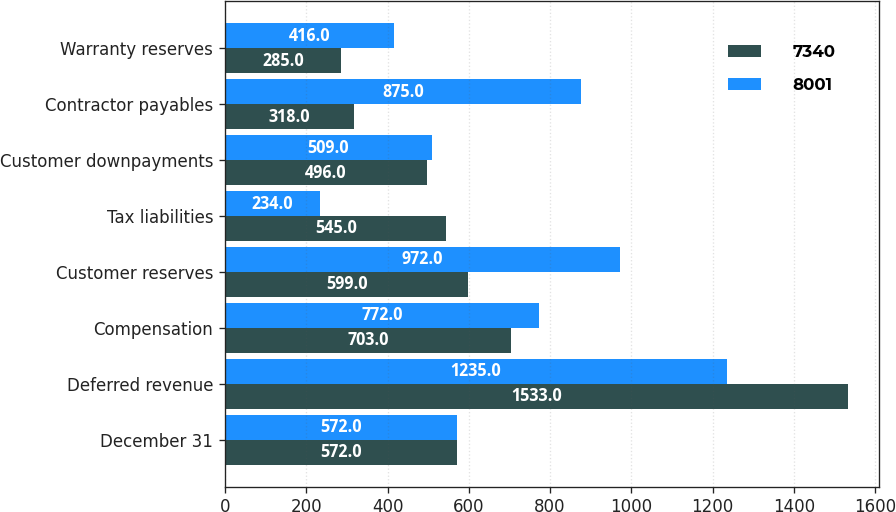<chart> <loc_0><loc_0><loc_500><loc_500><stacked_bar_chart><ecel><fcel>December 31<fcel>Deferred revenue<fcel>Compensation<fcel>Customer reserves<fcel>Tax liabilities<fcel>Customer downpayments<fcel>Contractor payables<fcel>Warranty reserves<nl><fcel>7340<fcel>572<fcel>1533<fcel>703<fcel>599<fcel>545<fcel>496<fcel>318<fcel>285<nl><fcel>8001<fcel>572<fcel>1235<fcel>772<fcel>972<fcel>234<fcel>509<fcel>875<fcel>416<nl></chart> 